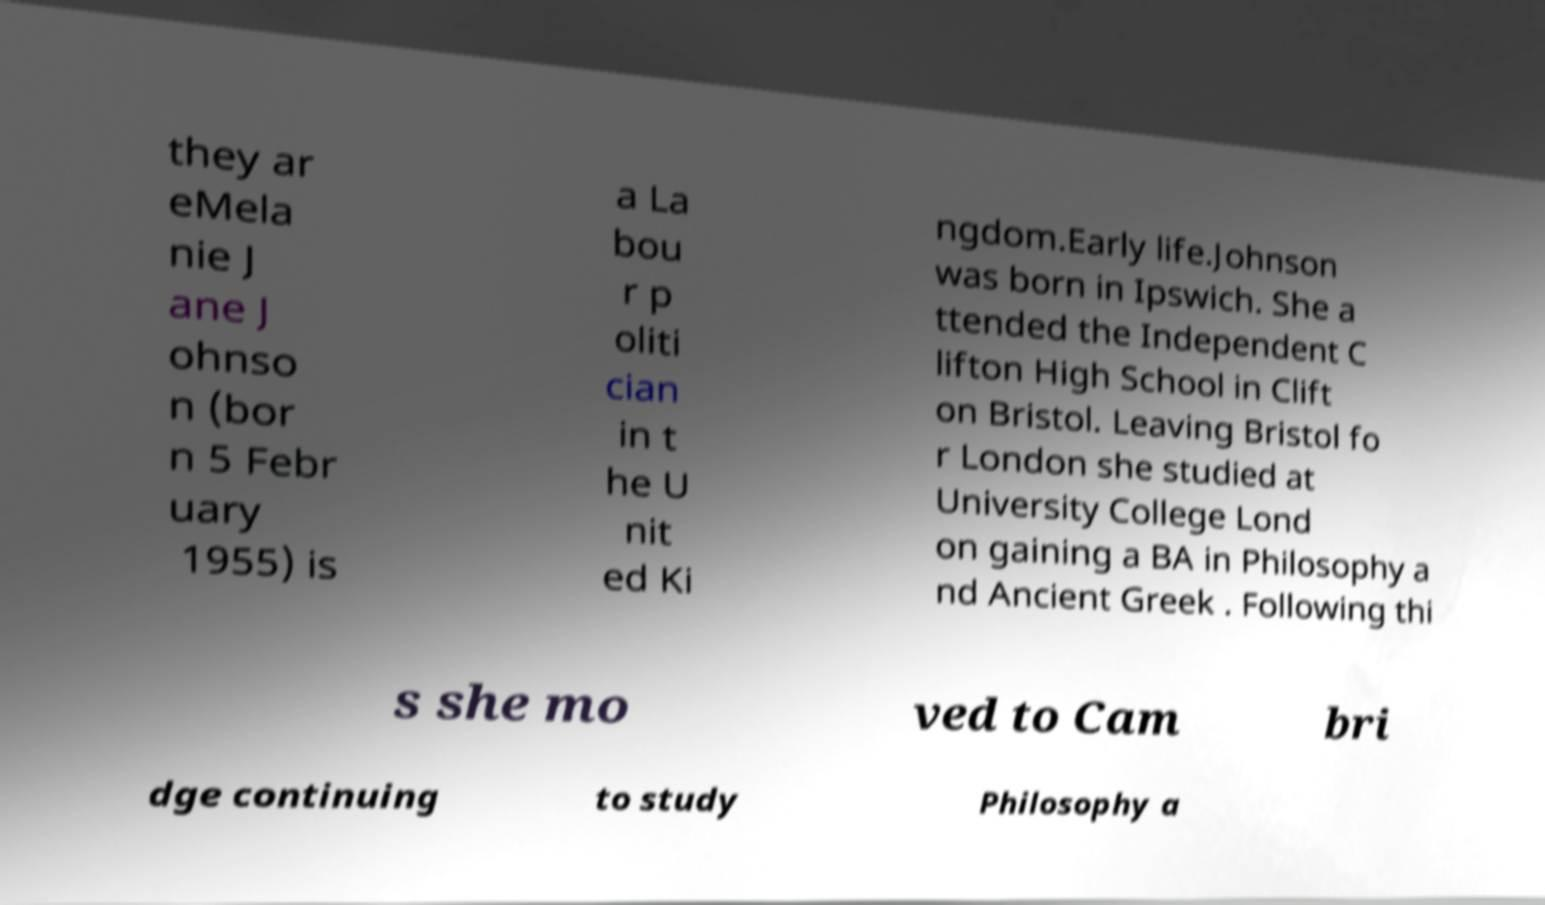Could you extract and type out the text from this image? they ar eMela nie J ane J ohnso n (bor n 5 Febr uary 1955) is a La bou r p oliti cian in t he U nit ed Ki ngdom.Early life.Johnson was born in Ipswich. She a ttended the Independent C lifton High School in Clift on Bristol. Leaving Bristol fo r London she studied at University College Lond on gaining a BA in Philosophy a nd Ancient Greek . Following thi s she mo ved to Cam bri dge continuing to study Philosophy a 